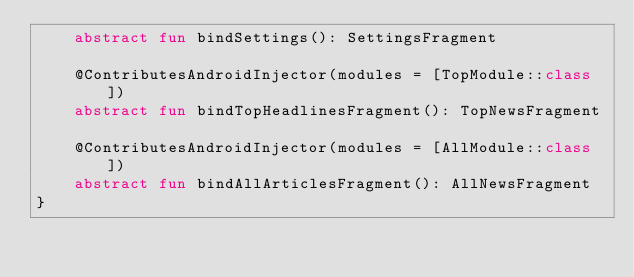<code> <loc_0><loc_0><loc_500><loc_500><_Kotlin_>    abstract fun bindSettings(): SettingsFragment

    @ContributesAndroidInjector(modules = [TopModule::class])
    abstract fun bindTopHeadlinesFragment(): TopNewsFragment

    @ContributesAndroidInjector(modules = [AllModule::class])
    abstract fun bindAllArticlesFragment(): AllNewsFragment
}</code> 